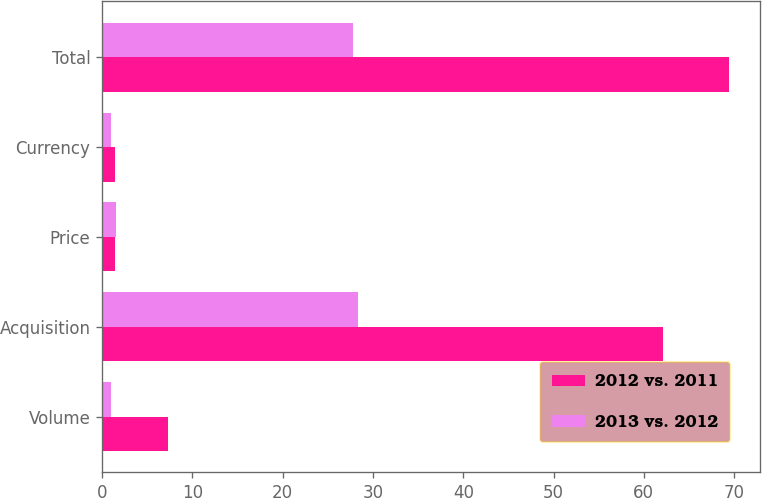Convert chart. <chart><loc_0><loc_0><loc_500><loc_500><stacked_bar_chart><ecel><fcel>Volume<fcel>Acquisition<fcel>Price<fcel>Currency<fcel>Total<nl><fcel>2012 vs. 2011<fcel>7.3<fcel>62.1<fcel>1.4<fcel>1.4<fcel>69.4<nl><fcel>2013 vs. 2012<fcel>1<fcel>28.3<fcel>1.5<fcel>1<fcel>27.8<nl></chart> 